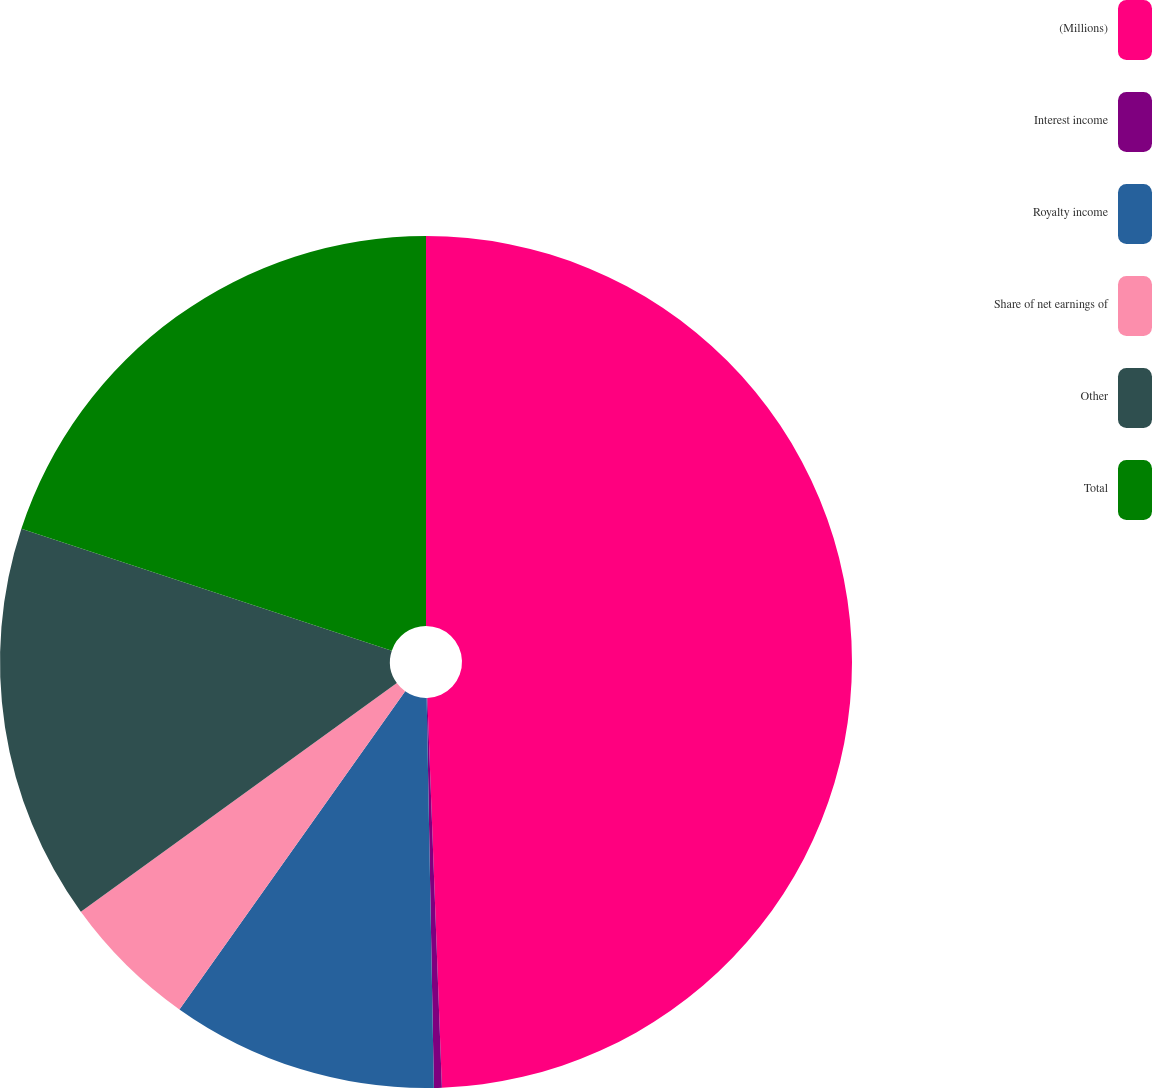Convert chart to OTSL. <chart><loc_0><loc_0><loc_500><loc_500><pie_chart><fcel>(Millions)<fcel>Interest income<fcel>Royalty income<fcel>Share of net earnings of<fcel>Other<fcel>Total<nl><fcel>49.41%<fcel>0.3%<fcel>10.12%<fcel>5.21%<fcel>15.03%<fcel>19.94%<nl></chart> 